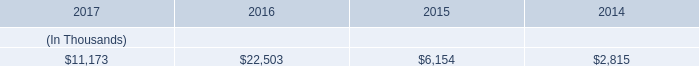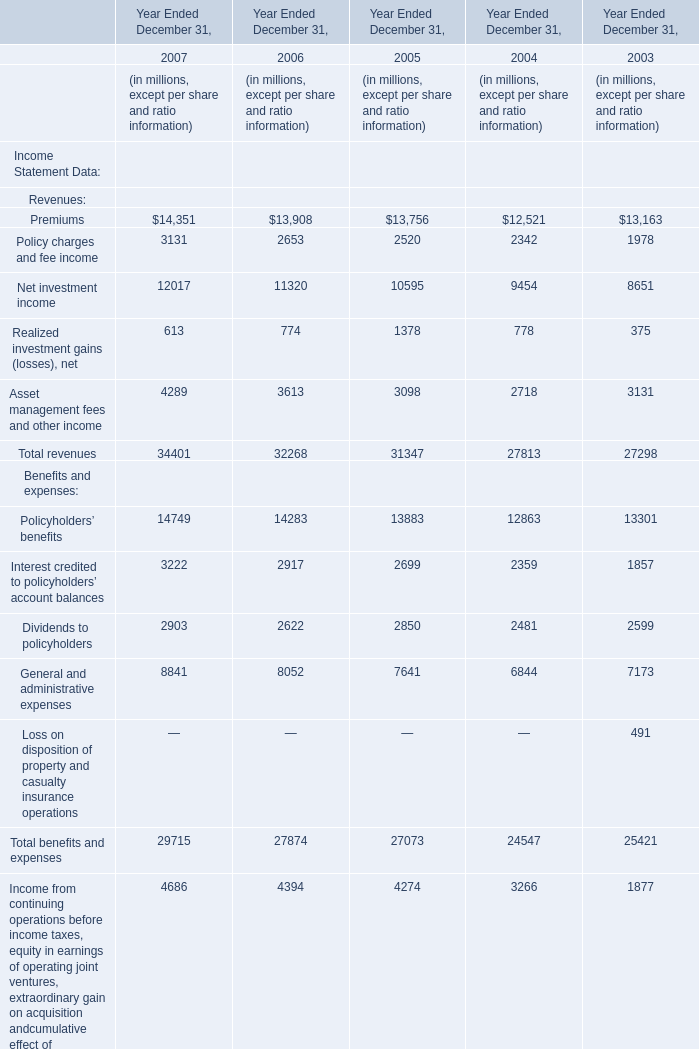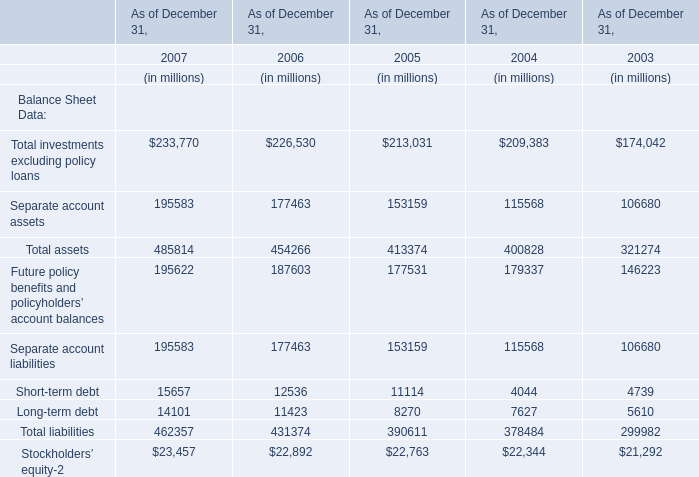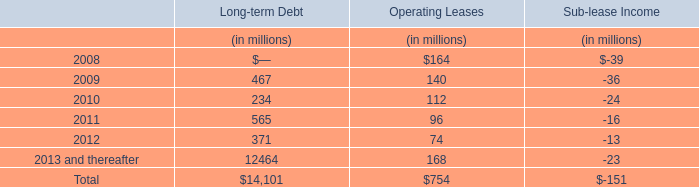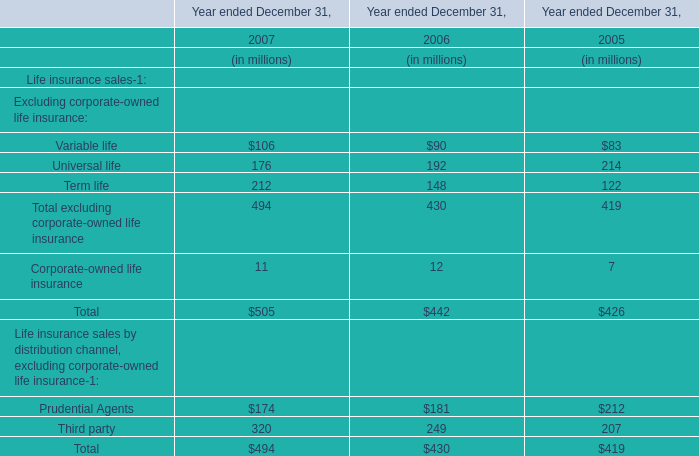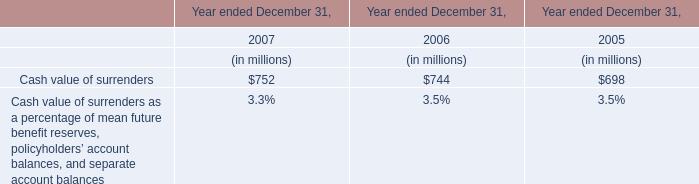In the year with largest amount of Net investment income, what's the increasing rate of Realized investment gains (losses), net? 
Computations: ((613 - 774) / 613)
Answer: -0.26264. 